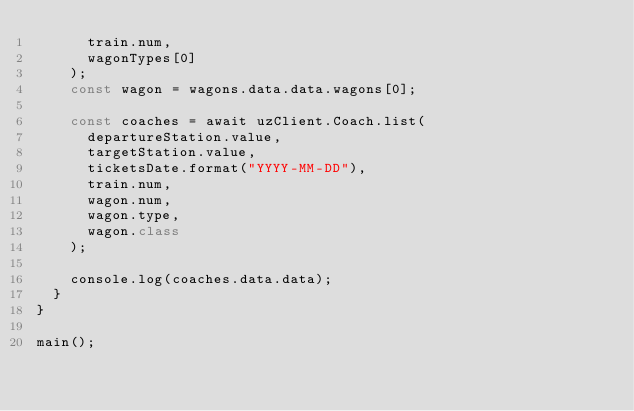Convert code to text. <code><loc_0><loc_0><loc_500><loc_500><_JavaScript_>      train.num,
      wagonTypes[0]
    );
    const wagon = wagons.data.data.wagons[0];

    const coaches = await uzClient.Coach.list(
      departureStation.value,
      targetStation.value,
      ticketsDate.format("YYYY-MM-DD"),
      train.num,
      wagon.num,
      wagon.type,
      wagon.class
    );

    console.log(coaches.data.data);
  }
}

main();
</code> 